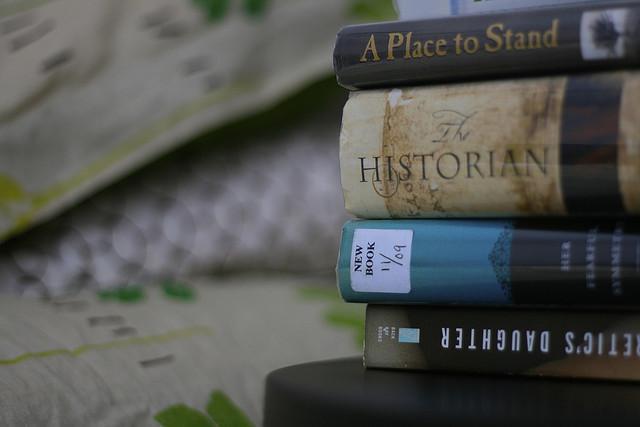How many books are visible?
Give a very brief answer. 4. 